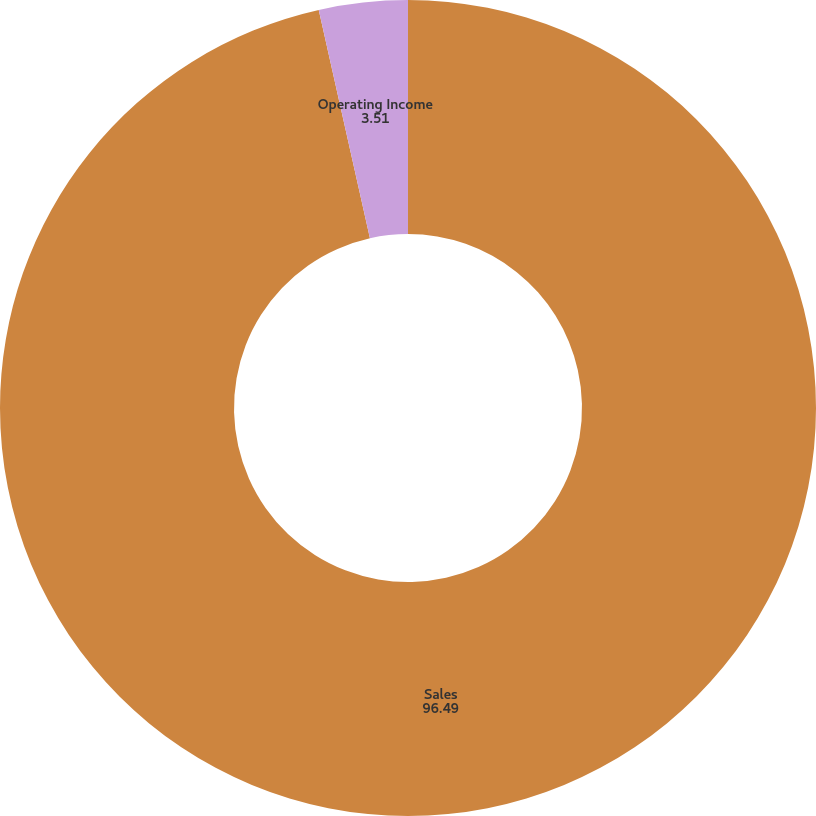Convert chart to OTSL. <chart><loc_0><loc_0><loc_500><loc_500><pie_chart><fcel>Sales<fcel>Operating Income<nl><fcel>96.49%<fcel>3.51%<nl></chart> 